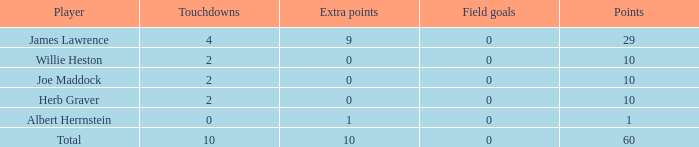What is the average number of field goals for players with more than 60 points? None. 